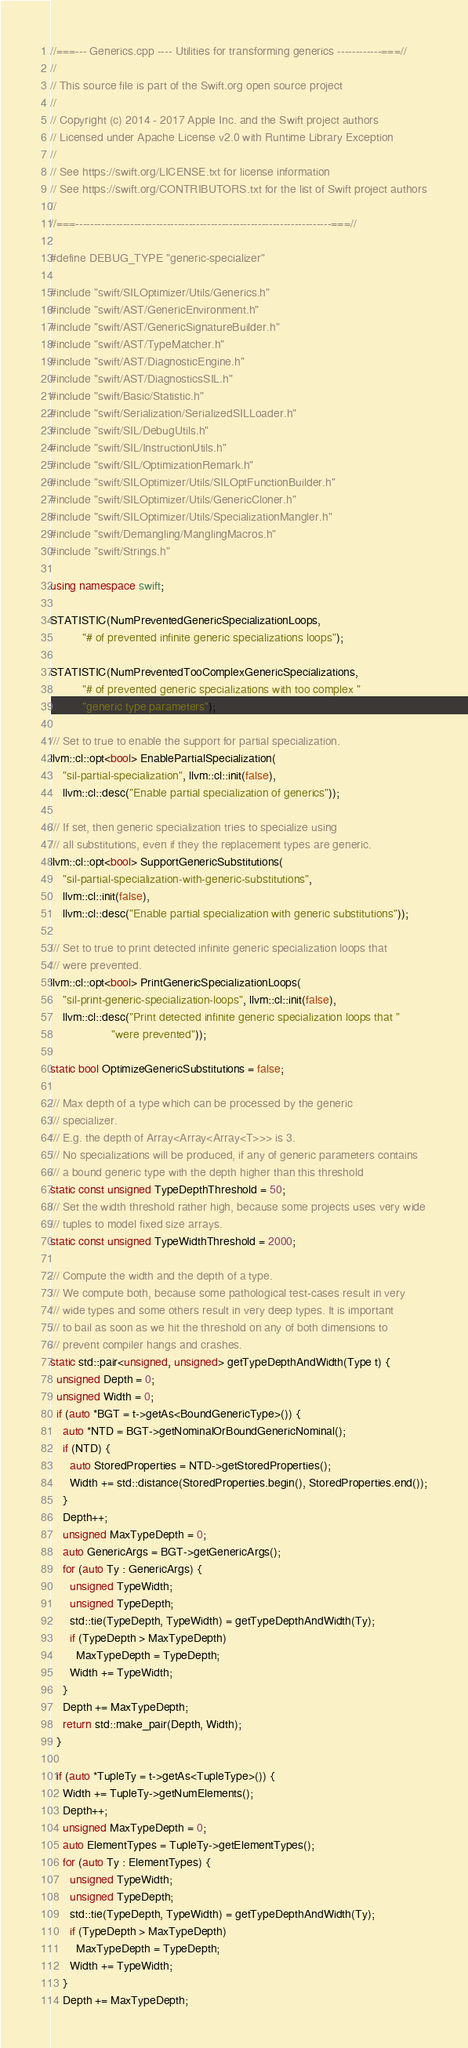<code> <loc_0><loc_0><loc_500><loc_500><_C++_>//===--- Generics.cpp ---- Utilities for transforming generics ------------===//
//
// This source file is part of the Swift.org open source project
//
// Copyright (c) 2014 - 2017 Apple Inc. and the Swift project authors
// Licensed under Apache License v2.0 with Runtime Library Exception
//
// See https://swift.org/LICENSE.txt for license information
// See https://swift.org/CONTRIBUTORS.txt for the list of Swift project authors
//
//===----------------------------------------------------------------------===//

#define DEBUG_TYPE "generic-specializer"

#include "swift/SILOptimizer/Utils/Generics.h"
#include "swift/AST/GenericEnvironment.h"
#include "swift/AST/GenericSignatureBuilder.h"
#include "swift/AST/TypeMatcher.h"
#include "swift/AST/DiagnosticEngine.h"
#include "swift/AST/DiagnosticsSIL.h"
#include "swift/Basic/Statistic.h"
#include "swift/Serialization/SerializedSILLoader.h"
#include "swift/SIL/DebugUtils.h"
#include "swift/SIL/InstructionUtils.h"
#include "swift/SIL/OptimizationRemark.h"
#include "swift/SILOptimizer/Utils/SILOptFunctionBuilder.h"
#include "swift/SILOptimizer/Utils/GenericCloner.h"
#include "swift/SILOptimizer/Utils/SpecializationMangler.h"
#include "swift/Demangling/ManglingMacros.h"
#include "swift/Strings.h"

using namespace swift;

STATISTIC(NumPreventedGenericSpecializationLoops,
          "# of prevented infinite generic specializations loops");

STATISTIC(NumPreventedTooComplexGenericSpecializations,
          "# of prevented generic specializations with too complex "
          "generic type parameters");

/// Set to true to enable the support for partial specialization.
llvm::cl::opt<bool> EnablePartialSpecialization(
    "sil-partial-specialization", llvm::cl::init(false),
    llvm::cl::desc("Enable partial specialization of generics"));

/// If set, then generic specialization tries to specialize using
/// all substitutions, even if they the replacement types are generic.
llvm::cl::opt<bool> SupportGenericSubstitutions(
    "sil-partial-specialization-with-generic-substitutions",
    llvm::cl::init(false),
    llvm::cl::desc("Enable partial specialization with generic substitutions"));

/// Set to true to print detected infinite generic specialization loops that
/// were prevented.
llvm::cl::opt<bool> PrintGenericSpecializationLoops(
    "sil-print-generic-specialization-loops", llvm::cl::init(false),
    llvm::cl::desc("Print detected infinite generic specialization loops that "
                   "were prevented"));

static bool OptimizeGenericSubstitutions = false;

/// Max depth of a type which can be processed by the generic
/// specializer.
/// E.g. the depth of Array<Array<Array<T>>> is 3.
/// No specializations will be produced, if any of generic parameters contains
/// a bound generic type with the depth higher than this threshold
static const unsigned TypeDepthThreshold = 50;
/// Set the width threshold rather high, because some projects uses very wide
/// tuples to model fixed size arrays.
static const unsigned TypeWidthThreshold = 2000;

/// Compute the width and the depth of a type.
/// We compute both, because some pathological test-cases result in very
/// wide types and some others result in very deep types. It is important
/// to bail as soon as we hit the threshold on any of both dimensions to
/// prevent compiler hangs and crashes.
static std::pair<unsigned, unsigned> getTypeDepthAndWidth(Type t) {
  unsigned Depth = 0;
  unsigned Width = 0;
  if (auto *BGT = t->getAs<BoundGenericType>()) {
    auto *NTD = BGT->getNominalOrBoundGenericNominal();
    if (NTD) {
      auto StoredProperties = NTD->getStoredProperties();
      Width += std::distance(StoredProperties.begin(), StoredProperties.end());
    }
    Depth++;
    unsigned MaxTypeDepth = 0;
    auto GenericArgs = BGT->getGenericArgs();
    for (auto Ty : GenericArgs) {
      unsigned TypeWidth;
      unsigned TypeDepth;
      std::tie(TypeDepth, TypeWidth) = getTypeDepthAndWidth(Ty);
      if (TypeDepth > MaxTypeDepth)
        MaxTypeDepth = TypeDepth;
      Width += TypeWidth;
    }
    Depth += MaxTypeDepth;
    return std::make_pair(Depth, Width);
  }

  if (auto *TupleTy = t->getAs<TupleType>()) {
    Width += TupleTy->getNumElements();
    Depth++;
    unsigned MaxTypeDepth = 0;
    auto ElementTypes = TupleTy->getElementTypes();
    for (auto Ty : ElementTypes) {
      unsigned TypeWidth;
      unsigned TypeDepth;
      std::tie(TypeDepth, TypeWidth) = getTypeDepthAndWidth(Ty);
      if (TypeDepth > MaxTypeDepth)
        MaxTypeDepth = TypeDepth;
      Width += TypeWidth;
    }
    Depth += MaxTypeDepth;</code> 